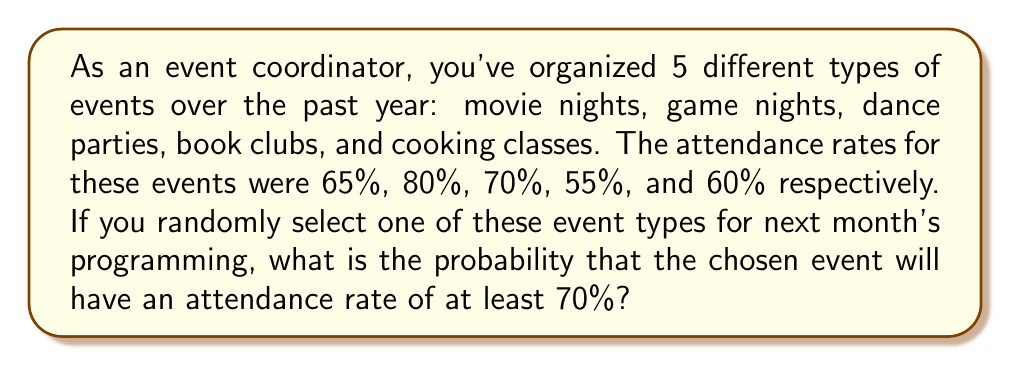Give your solution to this math problem. Let's approach this step-by-step:

1) First, we need to identify which events have an attendance rate of at least 70%:
   - Movie nights: 65% < 70%
   - Game nights: 80% ≥ 70%
   - Dance parties: 70% ≥ 70%
   - Book clubs: 55% < 70%
   - Cooking classes: 60% < 70%

2) We can see that only game nights and dance parties meet the criteria.

3) To calculate the probability, we use the formula:

   $$P(\text{attendance} \geq 70\%) = \frac{\text{number of favorable outcomes}}{\text{total number of possible outcomes}}$$

4) In this case:
   - Number of favorable outcomes (events with ≥70% attendance) = 2
   - Total number of possible outcomes (total number of event types) = 5

5) Substituting these values into our formula:

   $$P(\text{attendance} \geq 70\%) = \frac{2}{5} = 0.4$$

6) Therefore, the probability is 0.4 or 40%.
Answer: 0.4 